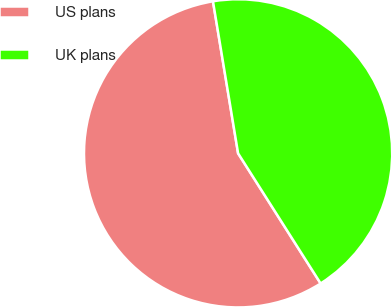Convert chart. <chart><loc_0><loc_0><loc_500><loc_500><pie_chart><fcel>US plans<fcel>UK plans<nl><fcel>56.39%<fcel>43.61%<nl></chart> 